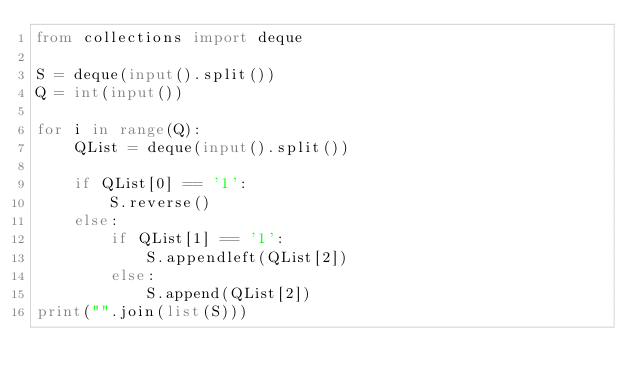Convert code to text. <code><loc_0><loc_0><loc_500><loc_500><_Python_>from collections import deque

S = deque(input().split())
Q = int(input())

for i in range(Q):
    QList = deque(input().split())
    
    if QList[0] == '1':
        S.reverse()
    else:
        if QList[1] == '1':
            S.appendleft(QList[2])
        else:
            S.append(QList[2])
print("".join(list(S)))</code> 